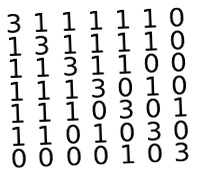<formula> <loc_0><loc_0><loc_500><loc_500>\begin{smallmatrix} 3 & 1 & 1 & 1 & 1 & 1 & 0 \\ 1 & 3 & 1 & 1 & 1 & 1 & 0 \\ 1 & 1 & 3 & 1 & 1 & 0 & 0 \\ 1 & 1 & 1 & 3 & 0 & 1 & 0 \\ 1 & 1 & 1 & 0 & 3 & 0 & 1 \\ 1 & 1 & 0 & 1 & 0 & 3 & 0 \\ 0 & 0 & 0 & 0 & 1 & 0 & 3 \end{smallmatrix}</formula> 